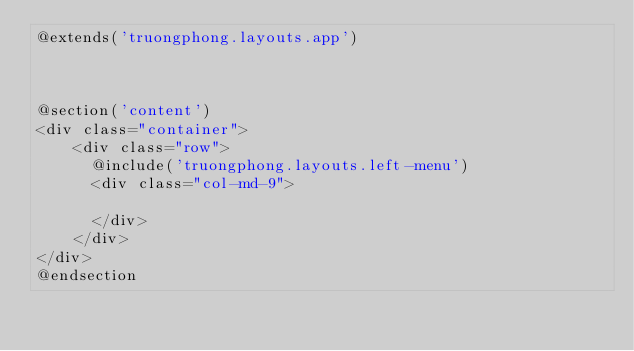Convert code to text. <code><loc_0><loc_0><loc_500><loc_500><_PHP_>@extends('truongphong.layouts.app')



@section('content')
<div class="container">
    <div class="row">
      @include('truongphong.layouts.left-menu')
      <div class="col-md-9">
          
      </div>
    </div>
</div>
@endsection
</code> 